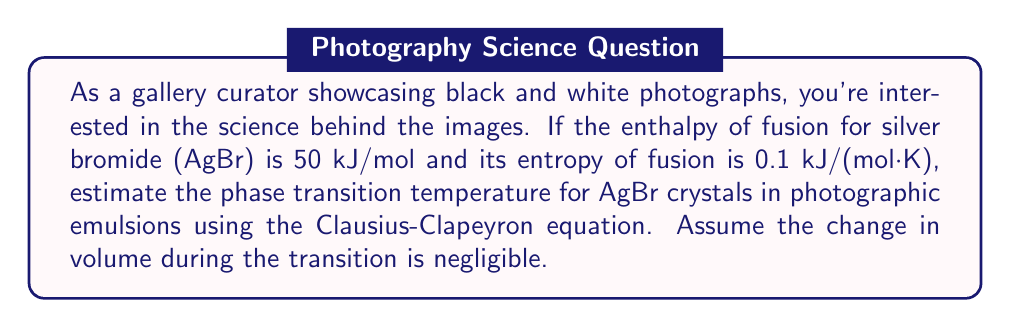Help me with this question. To estimate the phase transition temperature, we'll use the Clausius-Clapeyron equation in its simplified form for solid-liquid transitions:

$$\frac{\Delta H_f}{T_m} = \Delta S_f$$

Where:
$\Delta H_f$ = enthalpy of fusion
$T_m$ = melting temperature (phase transition temperature)
$\Delta S_f$ = entropy of fusion

Step 1: Identify the given values
$\Delta H_f = 50$ kJ/mol
$\Delta S_f = 0.1$ kJ/(mol·K)

Step 2: Rearrange the equation to solve for $T_m$
$$T_m = \frac{\Delta H_f}{\Delta S_f}$$

Step 3: Substitute the values and calculate
$$T_m = \frac{50 \text{ kJ/mol}}{0.1 \text{ kJ/(mol·K)}}$$

Step 4: Cancel out units and solve
$$T_m = 500 \text{ K}$$

Step 5: Convert to Celsius (optional, but useful for practical applications)
$$T_m = 500 \text{ K} - 273.15 = 226.85°\text{C}$$

This temperature represents the estimated phase transition (melting) point for silver bromide crystals in photographic emulsions.
Answer: 500 K (or 226.85°C) 